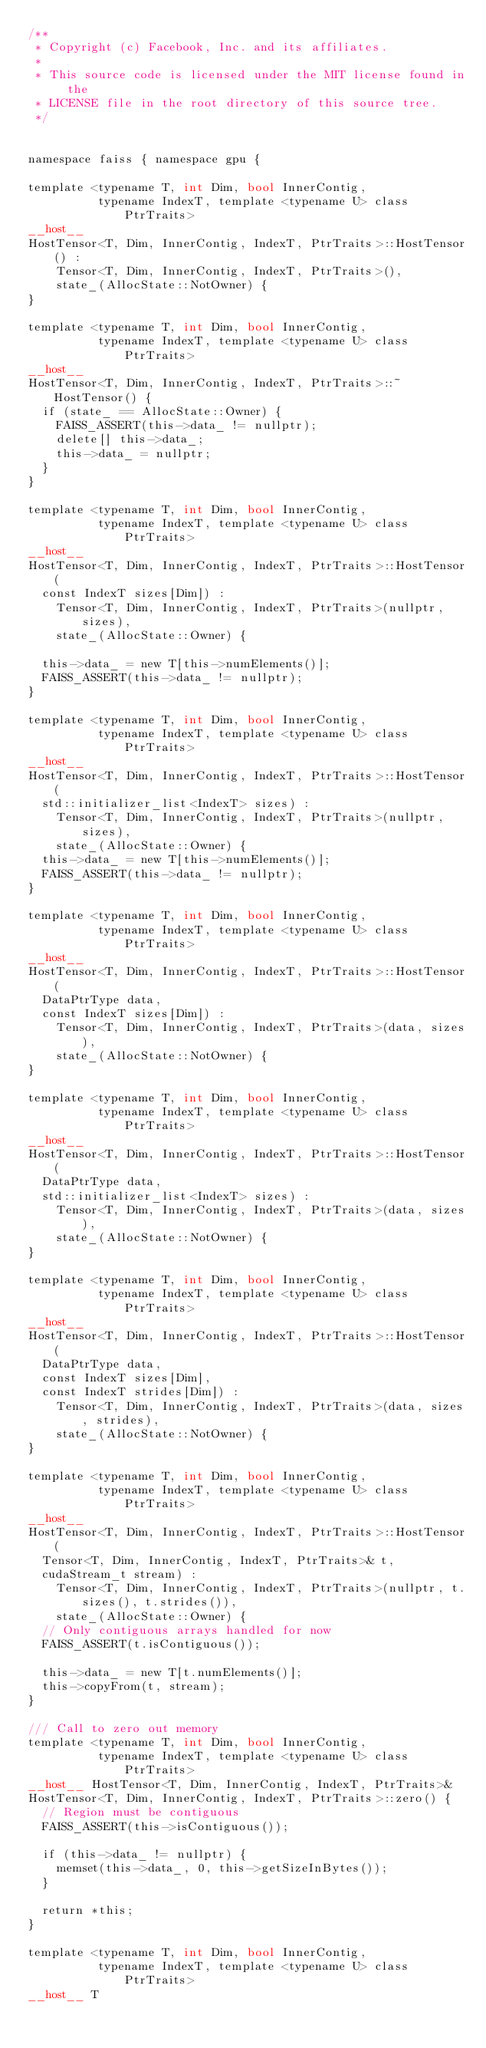Convert code to text. <code><loc_0><loc_0><loc_500><loc_500><_Cuda_>/**
 * Copyright (c) Facebook, Inc. and its affiliates.
 *
 * This source code is licensed under the MIT license found in the
 * LICENSE file in the root directory of this source tree.
 */


namespace faiss { namespace gpu {

template <typename T, int Dim, bool InnerContig,
          typename IndexT, template <typename U> class PtrTraits>
__host__
HostTensor<T, Dim, InnerContig, IndexT, PtrTraits>::HostTensor() :
    Tensor<T, Dim, InnerContig, IndexT, PtrTraits>(),
    state_(AllocState::NotOwner) {
}

template <typename T, int Dim, bool InnerContig,
          typename IndexT, template <typename U> class PtrTraits>
__host__
HostTensor<T, Dim, InnerContig, IndexT, PtrTraits>::~HostTensor() {
  if (state_ == AllocState::Owner) {
    FAISS_ASSERT(this->data_ != nullptr);
    delete[] this->data_;
    this->data_ = nullptr;
  }
}

template <typename T, int Dim, bool InnerContig,
          typename IndexT, template <typename U> class PtrTraits>
__host__
HostTensor<T, Dim, InnerContig, IndexT, PtrTraits>::HostTensor(
  const IndexT sizes[Dim]) :
    Tensor<T, Dim, InnerContig, IndexT, PtrTraits>(nullptr, sizes),
    state_(AllocState::Owner) {

  this->data_ = new T[this->numElements()];
  FAISS_ASSERT(this->data_ != nullptr);
}

template <typename T, int Dim, bool InnerContig,
          typename IndexT, template <typename U> class PtrTraits>
__host__
HostTensor<T, Dim, InnerContig, IndexT, PtrTraits>::HostTensor(
  std::initializer_list<IndexT> sizes) :
    Tensor<T, Dim, InnerContig, IndexT, PtrTraits>(nullptr, sizes),
    state_(AllocState::Owner) {
  this->data_ = new T[this->numElements()];
  FAISS_ASSERT(this->data_ != nullptr);
}

template <typename T, int Dim, bool InnerContig,
          typename IndexT, template <typename U> class PtrTraits>
__host__
HostTensor<T, Dim, InnerContig, IndexT, PtrTraits>::HostTensor(
  DataPtrType data,
  const IndexT sizes[Dim]) :
    Tensor<T, Dim, InnerContig, IndexT, PtrTraits>(data, sizes),
    state_(AllocState::NotOwner) {
}

template <typename T, int Dim, bool InnerContig,
          typename IndexT, template <typename U> class PtrTraits>
__host__
HostTensor<T, Dim, InnerContig, IndexT, PtrTraits>::HostTensor(
  DataPtrType data,
  std::initializer_list<IndexT> sizes) :
    Tensor<T, Dim, InnerContig, IndexT, PtrTraits>(data, sizes),
    state_(AllocState::NotOwner) {
}

template <typename T, int Dim, bool InnerContig,
          typename IndexT, template <typename U> class PtrTraits>
__host__
HostTensor<T, Dim, InnerContig, IndexT, PtrTraits>::HostTensor(
  DataPtrType data,
  const IndexT sizes[Dim],
  const IndexT strides[Dim]) :
    Tensor<T, Dim, InnerContig, IndexT, PtrTraits>(data, sizes, strides),
    state_(AllocState::NotOwner) {
}

template <typename T, int Dim, bool InnerContig,
          typename IndexT, template <typename U> class PtrTraits>
__host__
HostTensor<T, Dim, InnerContig, IndexT, PtrTraits>::HostTensor(
  Tensor<T, Dim, InnerContig, IndexT, PtrTraits>& t,
  cudaStream_t stream) :
    Tensor<T, Dim, InnerContig, IndexT, PtrTraits>(nullptr, t.sizes(), t.strides()),
    state_(AllocState::Owner) {
  // Only contiguous arrays handled for now
  FAISS_ASSERT(t.isContiguous());

  this->data_ = new T[t.numElements()];
  this->copyFrom(t, stream);
}

/// Call to zero out memory
template <typename T, int Dim, bool InnerContig,
          typename IndexT, template <typename U> class PtrTraits>
__host__ HostTensor<T, Dim, InnerContig, IndexT, PtrTraits>&
HostTensor<T, Dim, InnerContig, IndexT, PtrTraits>::zero() {
  // Region must be contiguous
  FAISS_ASSERT(this->isContiguous());

  if (this->data_ != nullptr) {
    memset(this->data_, 0, this->getSizeInBytes());
  }

  return *this;
}

template <typename T, int Dim, bool InnerContig,
          typename IndexT, template <typename U> class PtrTraits>
__host__ T</code> 